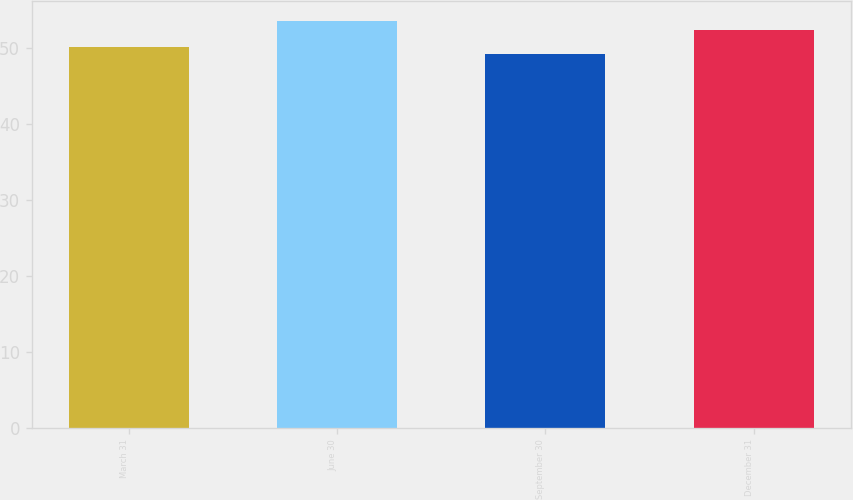Convert chart to OTSL. <chart><loc_0><loc_0><loc_500><loc_500><bar_chart><fcel>March 31<fcel>June 30<fcel>September 30<fcel>December 31<nl><fcel>50.1<fcel>53.58<fcel>49.18<fcel>52.46<nl></chart> 